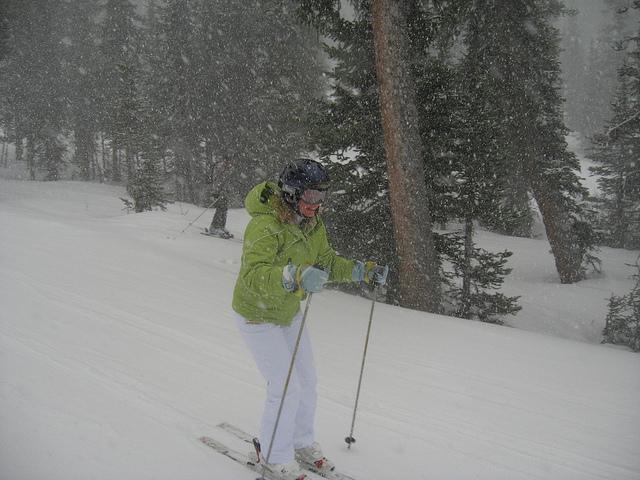How many birds are going to fly there in the image?
Give a very brief answer. 0. 